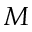<formula> <loc_0><loc_0><loc_500><loc_500>M</formula> 